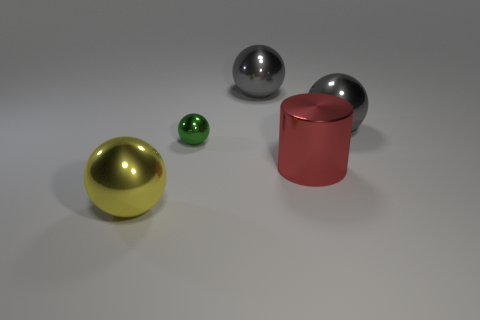What number of balls are right of the small metal object? 2 